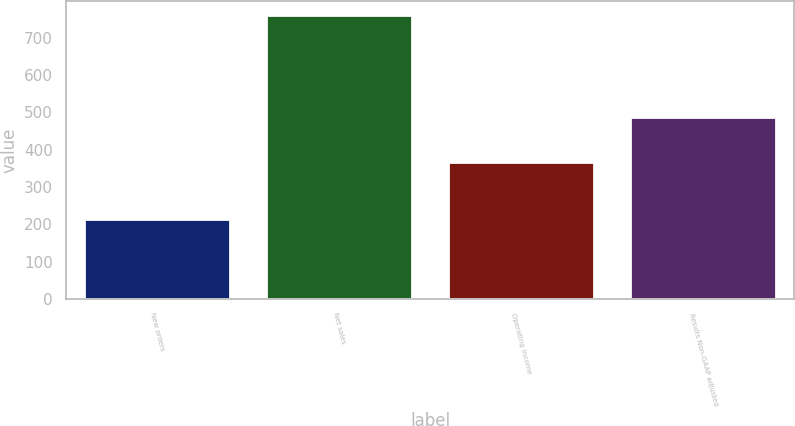<chart> <loc_0><loc_0><loc_500><loc_500><bar_chart><fcel>New orders<fcel>Net sales<fcel>Operating income<fcel>Results Non-GAAP adjusted<nl><fcel>213<fcel>761<fcel>367<fcel>487<nl></chart> 